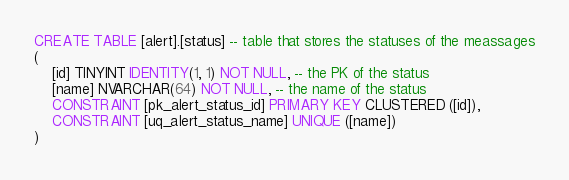<code> <loc_0><loc_0><loc_500><loc_500><_SQL_>CREATE TABLE [alert].[status] -- table that stores the statuses of the meassages
(
    [id] TINYINT IDENTITY(1, 1) NOT NULL, -- the PK of the status
    [name] NVARCHAR(64) NOT NULL, -- the name of the status
    CONSTRAINT [pk_alert_status_id] PRIMARY KEY CLUSTERED ([id]),
    CONSTRAINT [uq_alert_status_name] UNIQUE ([name])
)
</code> 